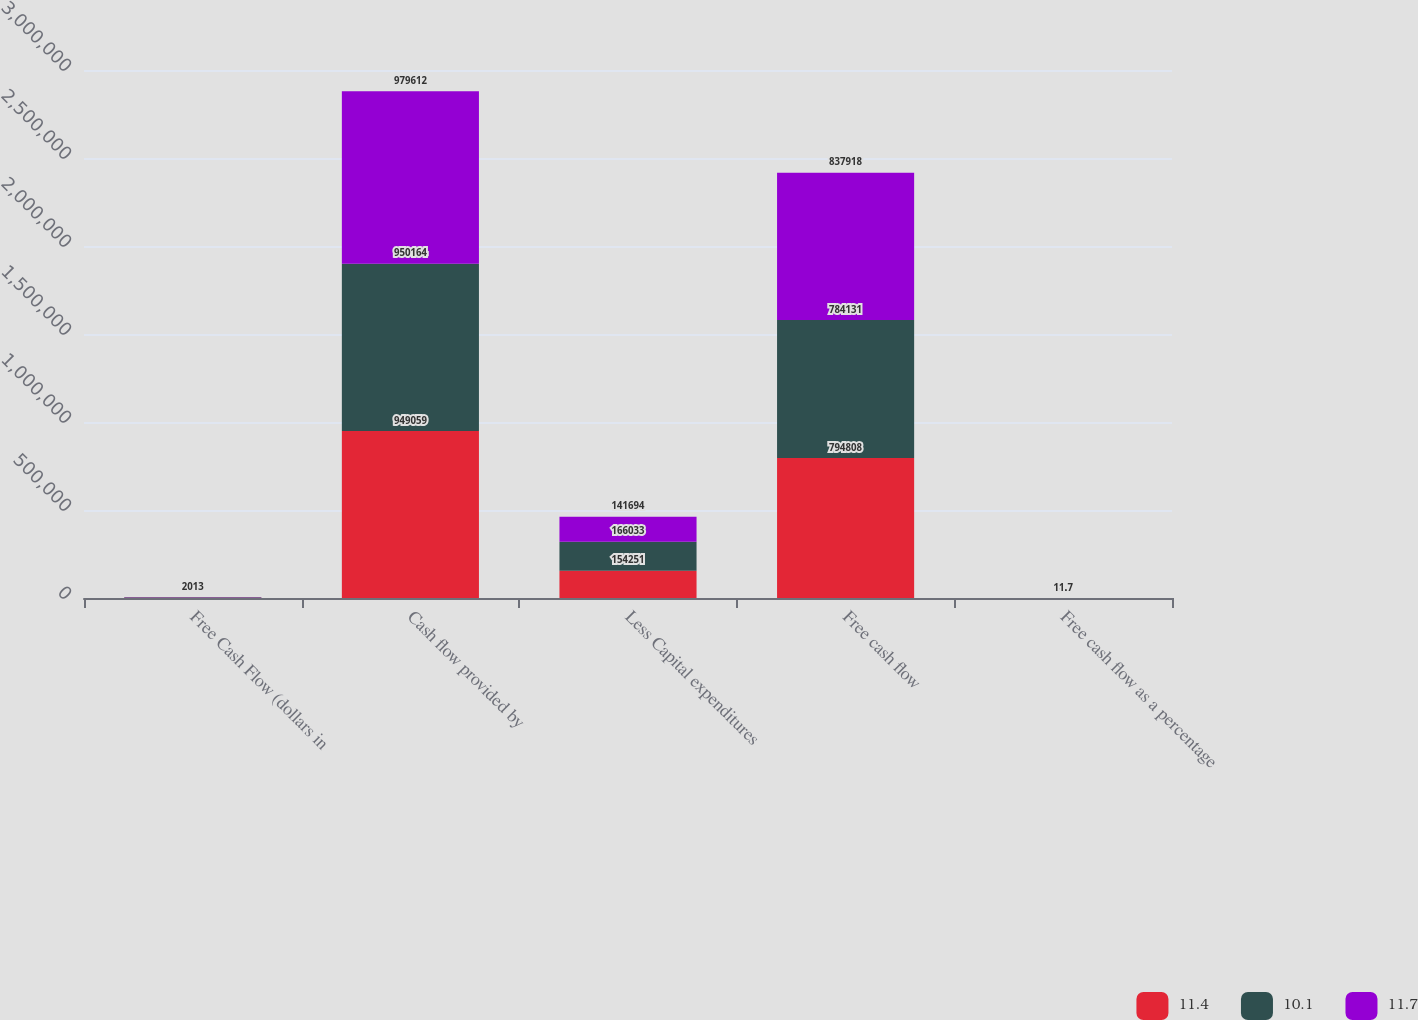Convert chart to OTSL. <chart><loc_0><loc_0><loc_500><loc_500><stacked_bar_chart><ecel><fcel>Free Cash Flow (dollars in<fcel>Cash flow provided by<fcel>Less Capital expenditures<fcel>Free cash flow<fcel>Free cash flow as a percentage<nl><fcel>11.4<fcel>2015<fcel>949059<fcel>154251<fcel>794808<fcel>11.4<nl><fcel>10.1<fcel>2014<fcel>950164<fcel>166033<fcel>784131<fcel>10.1<nl><fcel>11.7<fcel>2013<fcel>979612<fcel>141694<fcel>837918<fcel>11.7<nl></chart> 